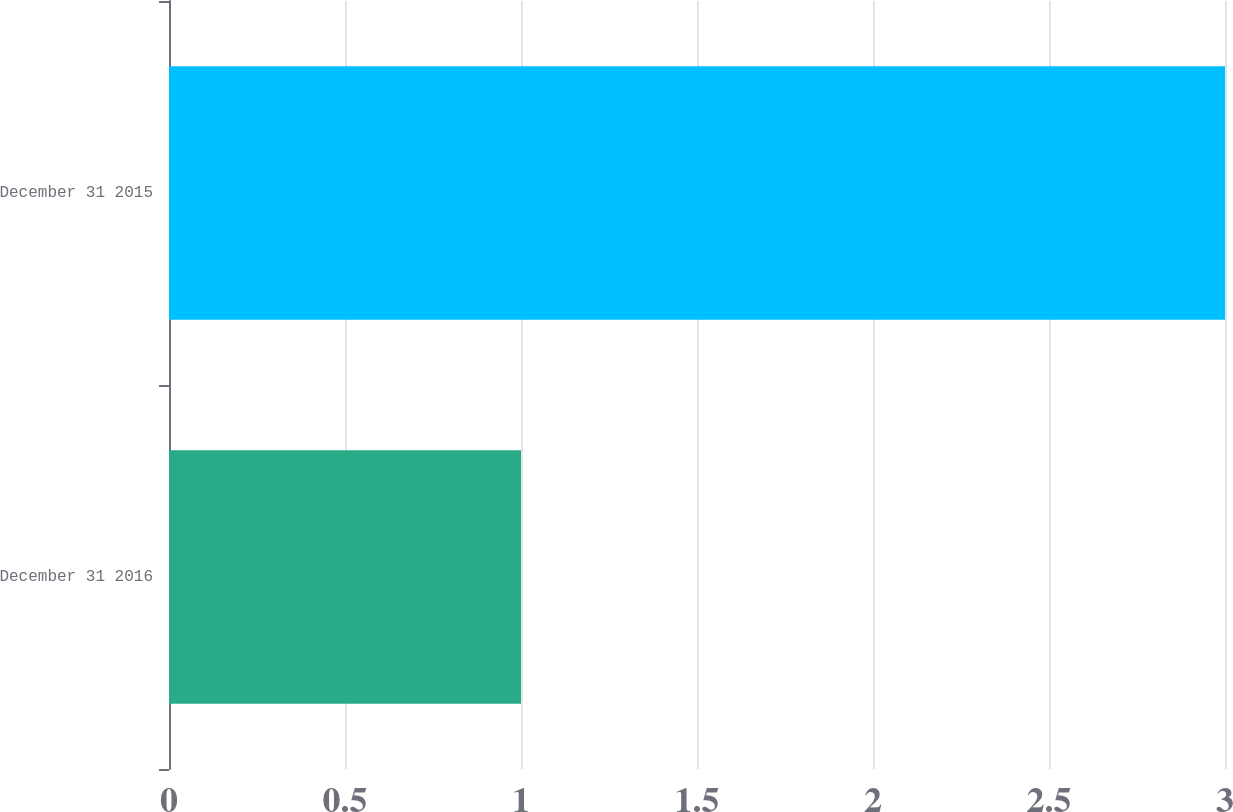Convert chart to OTSL. <chart><loc_0><loc_0><loc_500><loc_500><bar_chart><fcel>December 31 2016<fcel>December 31 2015<nl><fcel>1<fcel>3<nl></chart> 